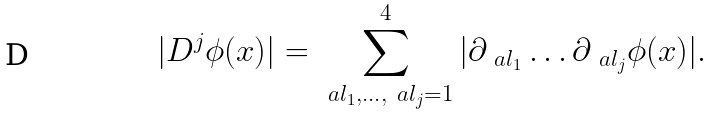<formula> <loc_0><loc_0><loc_500><loc_500>| D ^ { j } \phi ( x ) | = \sum _ { \ a l _ { 1 } , \dots , \ a l _ { j } = 1 } ^ { 4 } | \partial _ { \ a l _ { 1 } } \dots \partial _ { \ a l _ { j } } \phi ( x ) | .</formula> 